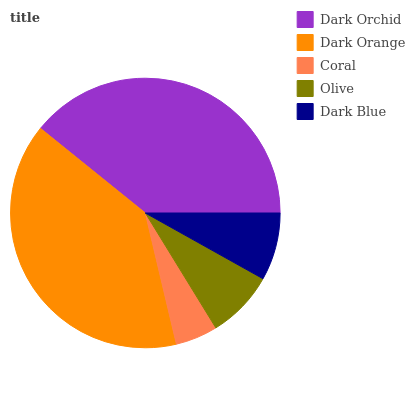Is Coral the minimum?
Answer yes or no. Yes. Is Dark Orange the maximum?
Answer yes or no. Yes. Is Dark Orange the minimum?
Answer yes or no. No. Is Coral the maximum?
Answer yes or no. No. Is Dark Orange greater than Coral?
Answer yes or no. Yes. Is Coral less than Dark Orange?
Answer yes or no. Yes. Is Coral greater than Dark Orange?
Answer yes or no. No. Is Dark Orange less than Coral?
Answer yes or no. No. Is Olive the high median?
Answer yes or no. Yes. Is Olive the low median?
Answer yes or no. Yes. Is Coral the high median?
Answer yes or no. No. Is Dark Orange the low median?
Answer yes or no. No. 